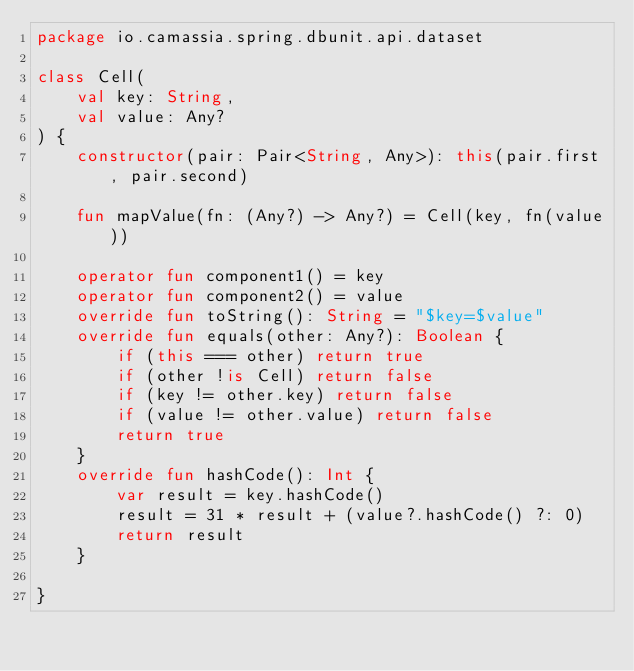<code> <loc_0><loc_0><loc_500><loc_500><_Kotlin_>package io.camassia.spring.dbunit.api.dataset

class Cell(
    val key: String,
    val value: Any?
) {
    constructor(pair: Pair<String, Any>): this(pair.first, pair.second)

    fun mapValue(fn: (Any?) -> Any?) = Cell(key, fn(value))

    operator fun component1() = key
    operator fun component2() = value
    override fun toString(): String = "$key=$value"
    override fun equals(other: Any?): Boolean {
        if (this === other) return true
        if (other !is Cell) return false
        if (key != other.key) return false
        if (value != other.value) return false
        return true
    }
    override fun hashCode(): Int {
        var result = key.hashCode()
        result = 31 * result + (value?.hashCode() ?: 0)
        return result
    }

}</code> 